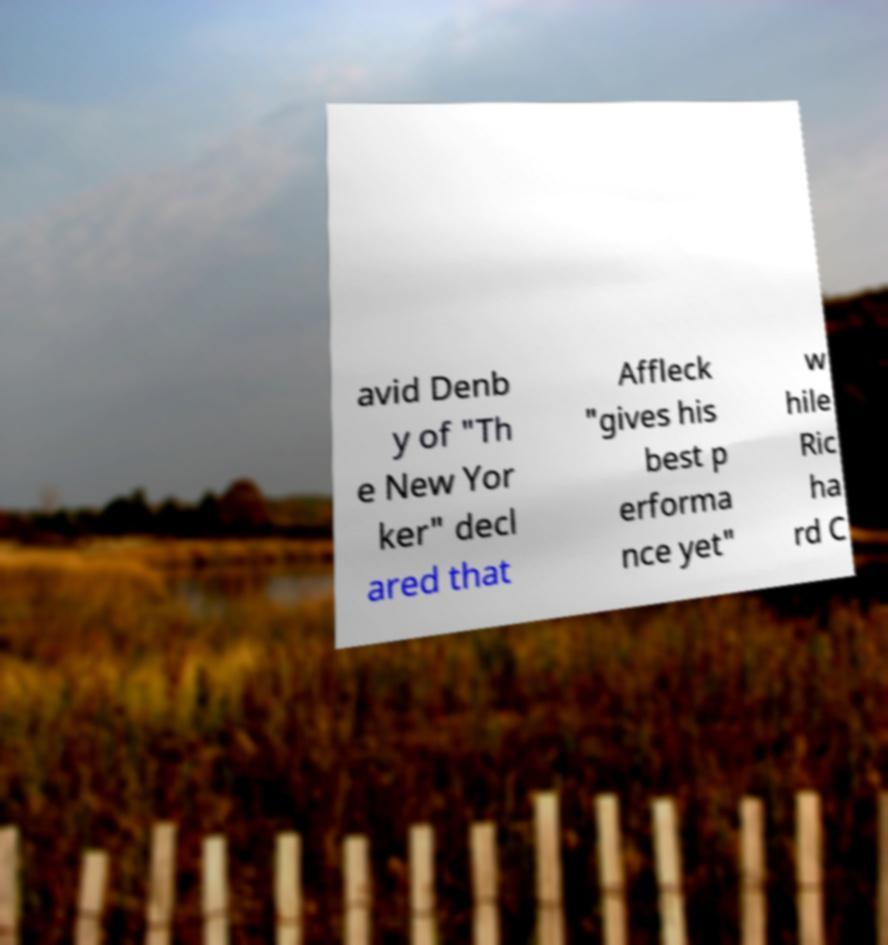What messages or text are displayed in this image? I need them in a readable, typed format. avid Denb y of "Th e New Yor ker" decl ared that Affleck "gives his best p erforma nce yet" w hile Ric ha rd C 